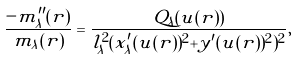<formula> <loc_0><loc_0><loc_500><loc_500>\frac { - m _ { \lambda } ^ { \prime \prime } ( r ) } { m _ { \lambda } ( r ) } = \frac { Q _ { \lambda } ( u ( r ) ) } { l _ { \lambda } ^ { 2 } ( x _ { \lambda } ^ { \prime } ( u ( r ) ) ^ { 2 } + y ^ { \prime } ( u ( r ) ) ^ { 2 } ) ^ { 2 } } ,</formula> 